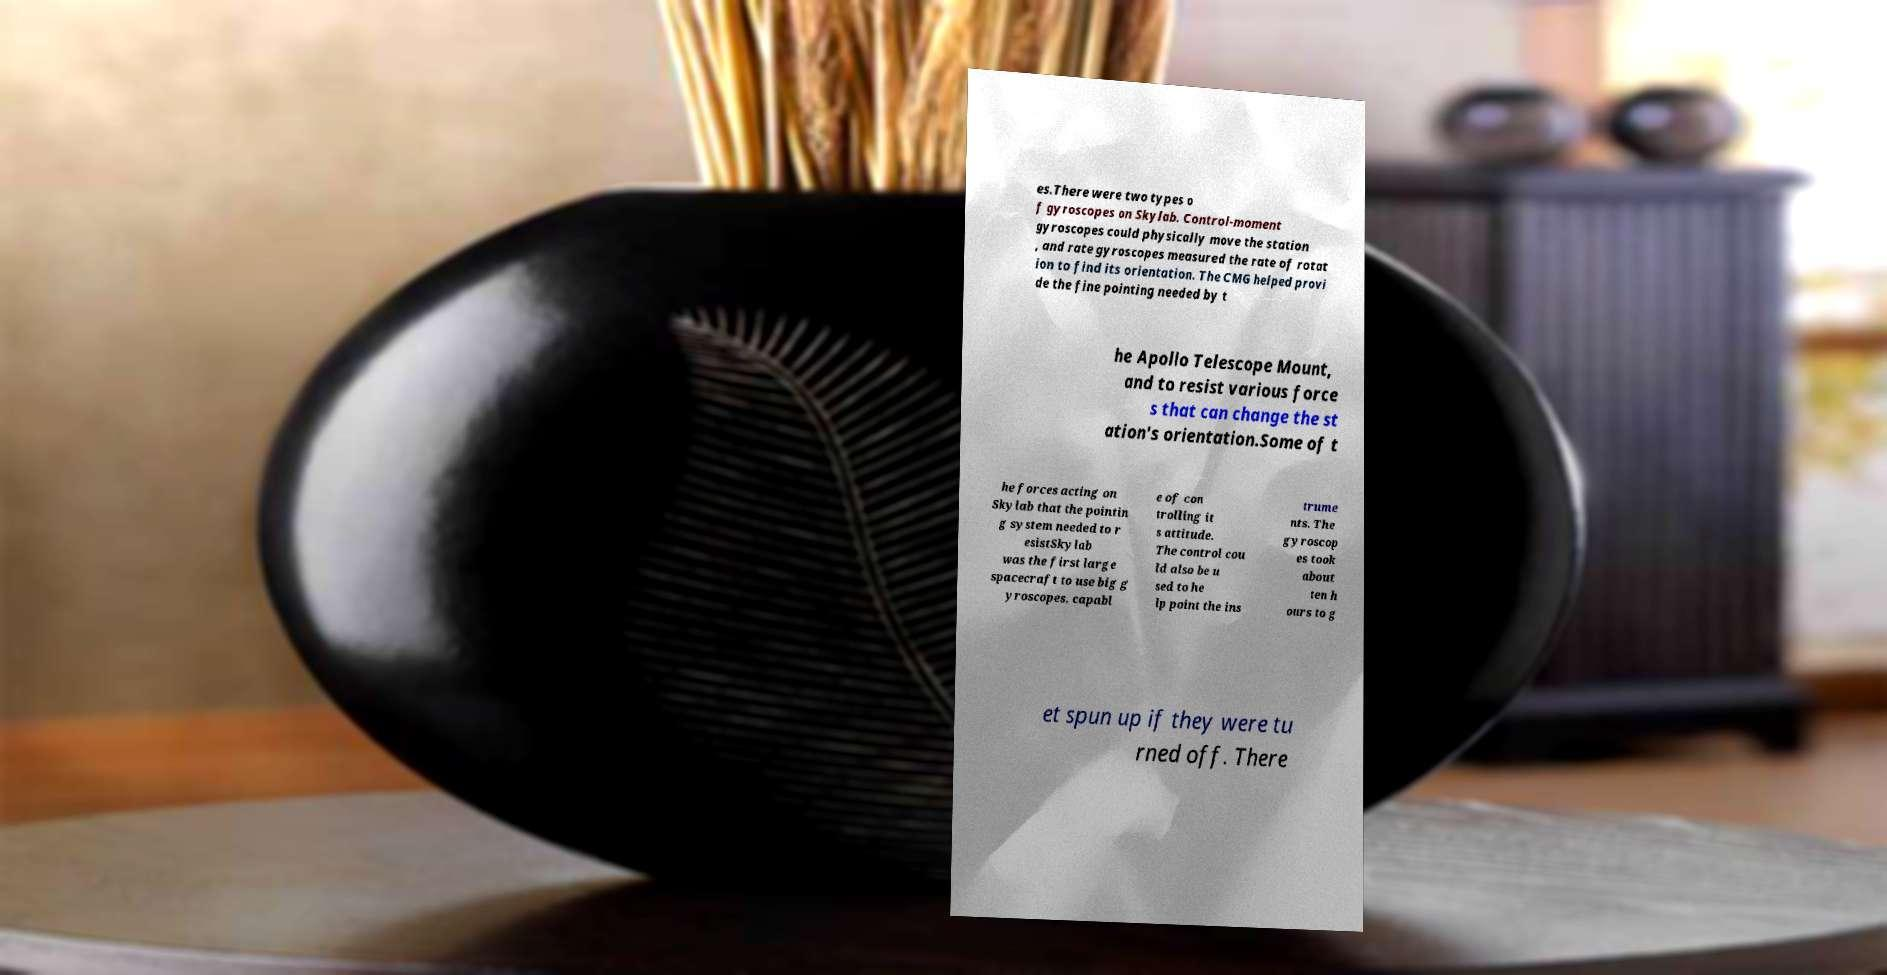There's text embedded in this image that I need extracted. Can you transcribe it verbatim? es.There were two types o f gyroscopes on Skylab. Control-moment gyroscopes could physically move the station , and rate gyroscopes measured the rate of rotat ion to find its orientation. The CMG helped provi de the fine pointing needed by t he Apollo Telescope Mount, and to resist various force s that can change the st ation's orientation.Some of t he forces acting on Skylab that the pointin g system needed to r esistSkylab was the first large spacecraft to use big g yroscopes, capabl e of con trolling it s attitude. The control cou ld also be u sed to he lp point the ins trume nts. The gyroscop es took about ten h ours to g et spun up if they were tu rned off. There 